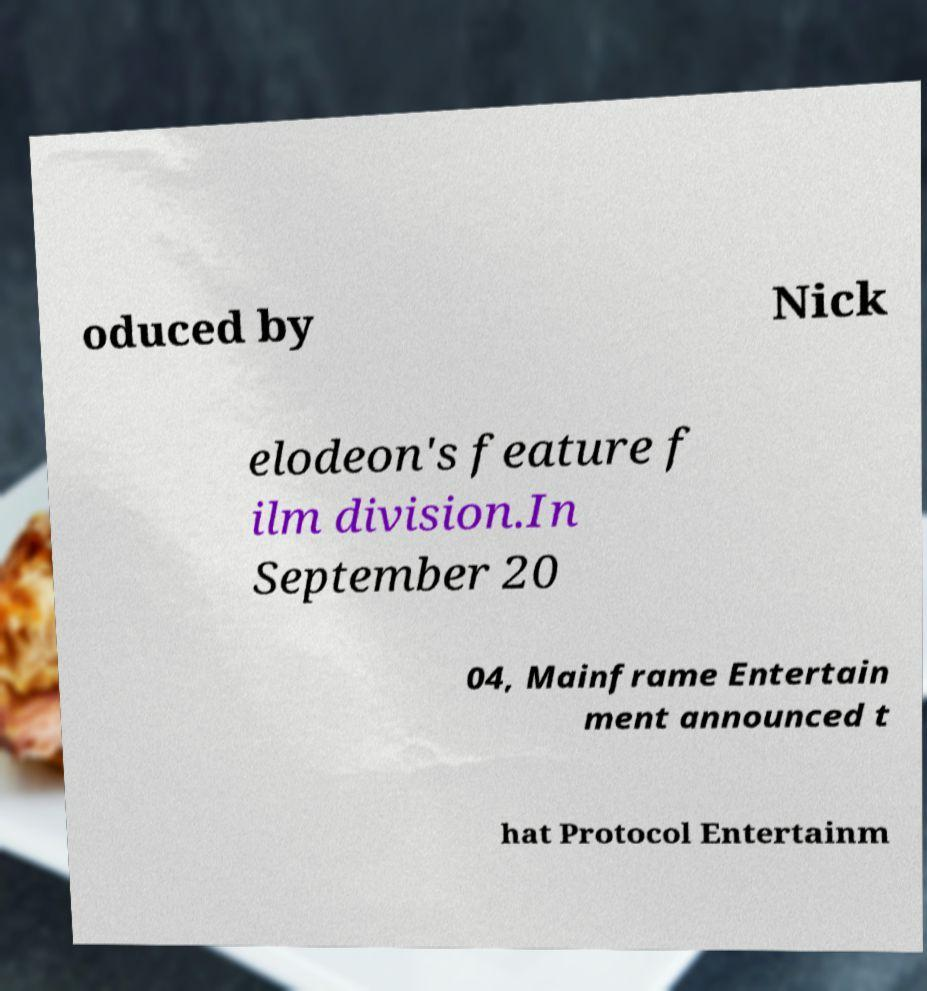For documentation purposes, I need the text within this image transcribed. Could you provide that? oduced by Nick elodeon's feature f ilm division.In September 20 04, Mainframe Entertain ment announced t hat Protocol Entertainm 